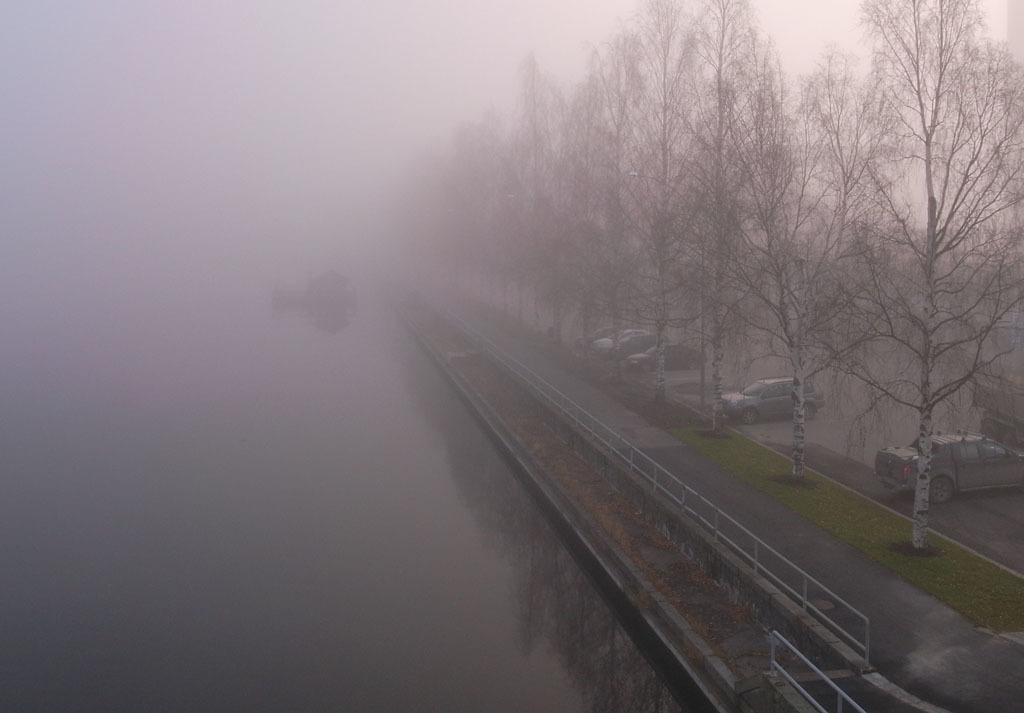What is the primary feature of the landscape in the image? There is snow in the image. What type of man-made structure can be seen in the image? There is a road in the image. What are the vehicles doing in the image? The vehicles are parked beside the road. What natural elements are present between the road? There are trees between the road. Can you see a bone sticking out of the snow in the image? There is no bone visible in the image; it only features snow, a road, parked vehicles, and trees. Are there any monkeys climbing the trees in the image? There are no monkeys present in the image; it only features snow, a road, parked vehicles, and trees. 